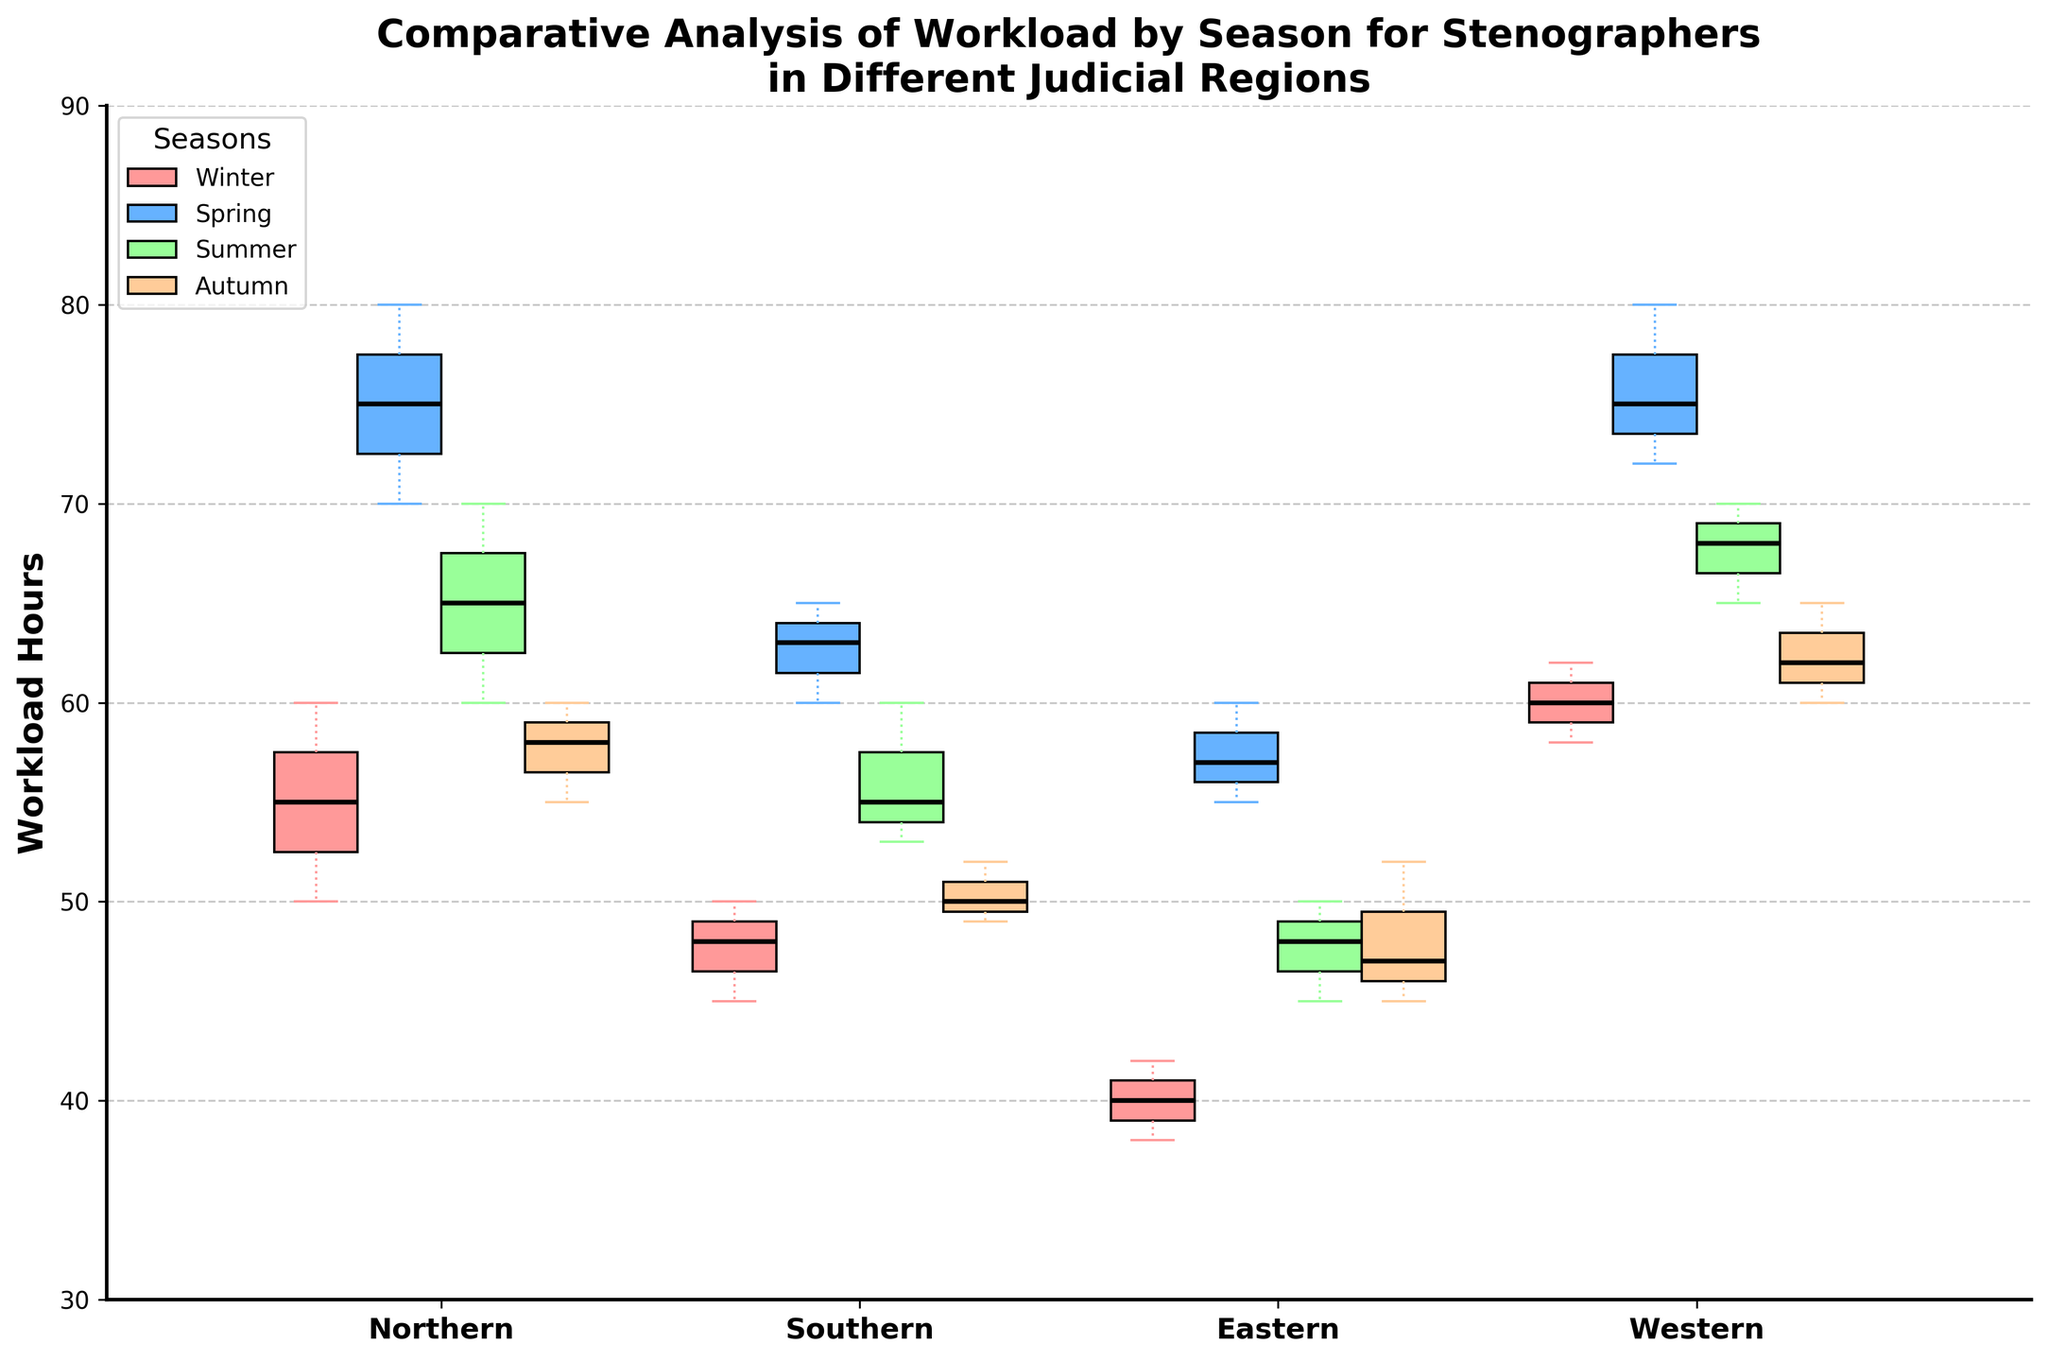What's the title of the figure? The title is displayed at the top of the figure in bold font, which indicates the main purpose of the plot. The title reads 'Comparative Analysis of Workload by Season for Stenographers in Different Judicial Regions'.
Answer: Comparative Analysis of Workload by Season for Stenographers in Different Judicial Regions What are the four seasons represented in the legend? The legend is located in the upper left corner and lists the four seasons represented by colored rectangles. These seasons are Winter, Spring, Summer, and Autumn.
Answer: Winter, Spring, Summer, Autumn Which region has the highest median workload hours in Spring? Look at the medians (solid bold lines) of the Spring box plots for each region. The Western region has the highest median workload in Spring, as it is the highest among the four.
Answer: Western Is the median workload in the Northern region higher in Winter or Summer? Compare the locations of the median lines (black lines) in the Winter and Summer box plots for the Northern region. The median in Summer is higher than in Winter for the Northern region.
Answer: Summer What is the range of workload hours in the Southern region during Autumn? The range is determined by the upper and lower whiskers of the Autumn box plot for the Southern region. The lower whisker is at 49 and the upper whisker is at 52, making the range 52 - 49 = 3 hours.
Answer: 3 hours Which season shows the smallest interquartile range (IQR) for workload hours in the Eastern region? The IQR is the distance between the upper and lower quartiles (edges of the box). For the Eastern region, Winter has the smallest IQR, as the box for Winter is the narrowest among all seasons.
Answer: Winter Overall, which region shows the most variability in workload hours? Variability can be assessed by looking at the spread and range of the data (length of whiskers and variance in box lengths). The Western region shows the most variability, especially noticeable in Spring and Autumn seasons.
Answer: Western How does the workload change from Winter to Spring in the Northern region? Compare the box plots for Winter and Spring in the Northern region. The median workload increases, and the interquartile range also appears to widen, indicating a higher workload and more variability in Spring.
Answer: Increases Which season tends to have the lowest workload across all regions? By comparing the median lines for each season across all regions, Winter generally has the lowest median workload compared to other seasons.
Answer: Winter Are there any regions where the workloads in Summer are generally lower than in Spring? Look at the box plots for Spring and Summer for each region. Both Northern and Southern regions show lower median workloads in Summer compared to Spring.
Answer: Northern, Southern 